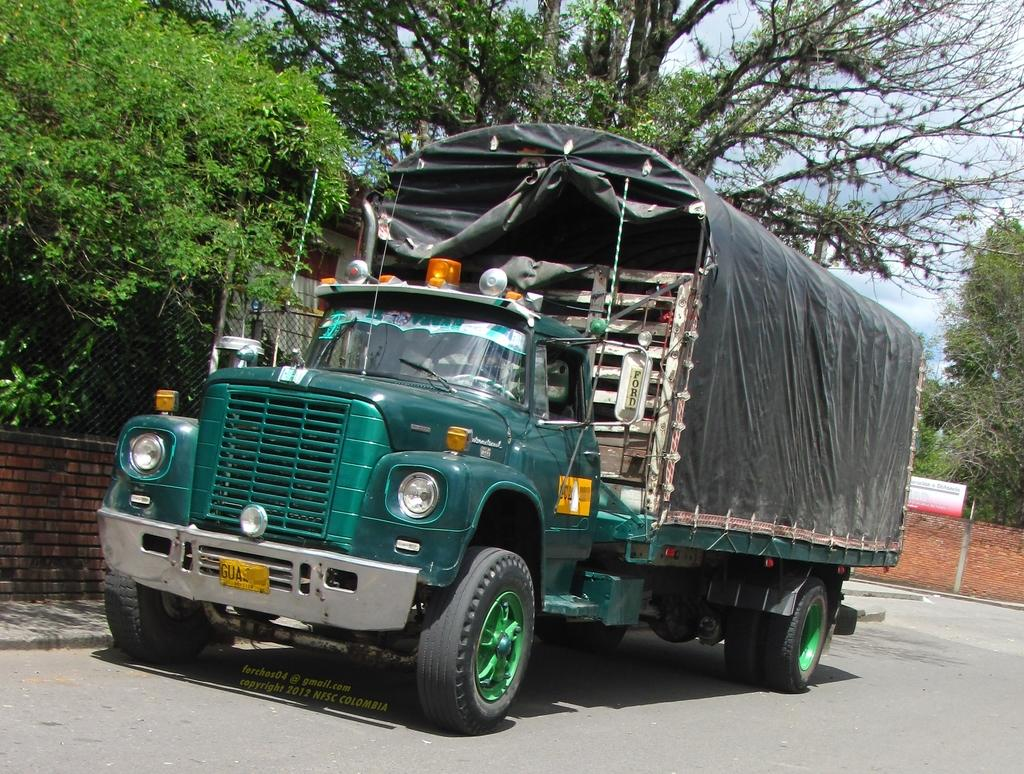What type of vehicle is in the image? There is a green color truck in the image. Where is the truck located? The truck is on the road. What can be seen on the left side of the image? There is a fence on the left side of the image. What is visible in the background of the image? There are trees and the sky visible in the background of the image. Can you see a woman holding a rifle and a quill in the image? No, there is no woman, rifle, or quill present in the image. 